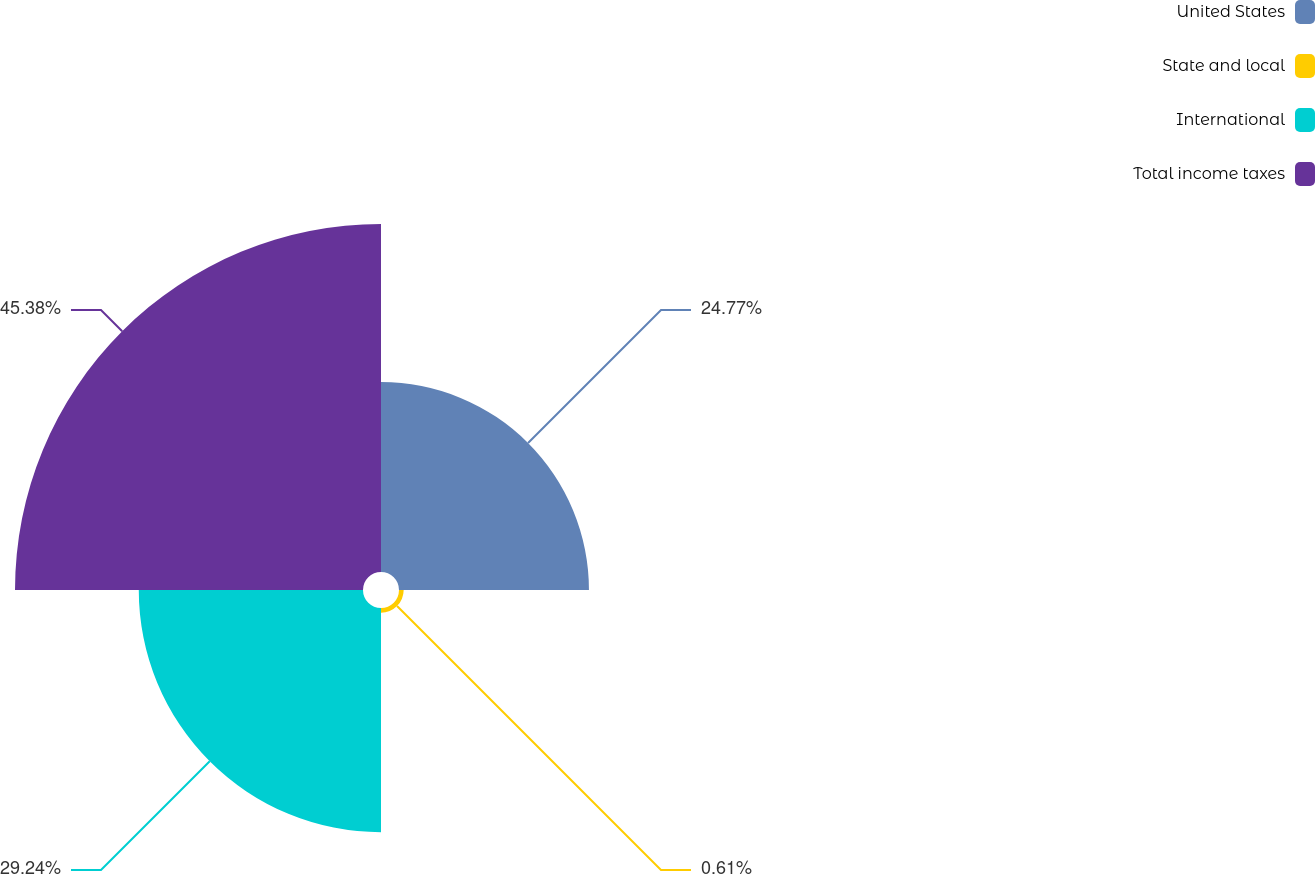Convert chart to OTSL. <chart><loc_0><loc_0><loc_500><loc_500><pie_chart><fcel>United States<fcel>State and local<fcel>International<fcel>Total income taxes<nl><fcel>24.77%<fcel>0.61%<fcel>29.24%<fcel>45.38%<nl></chart> 